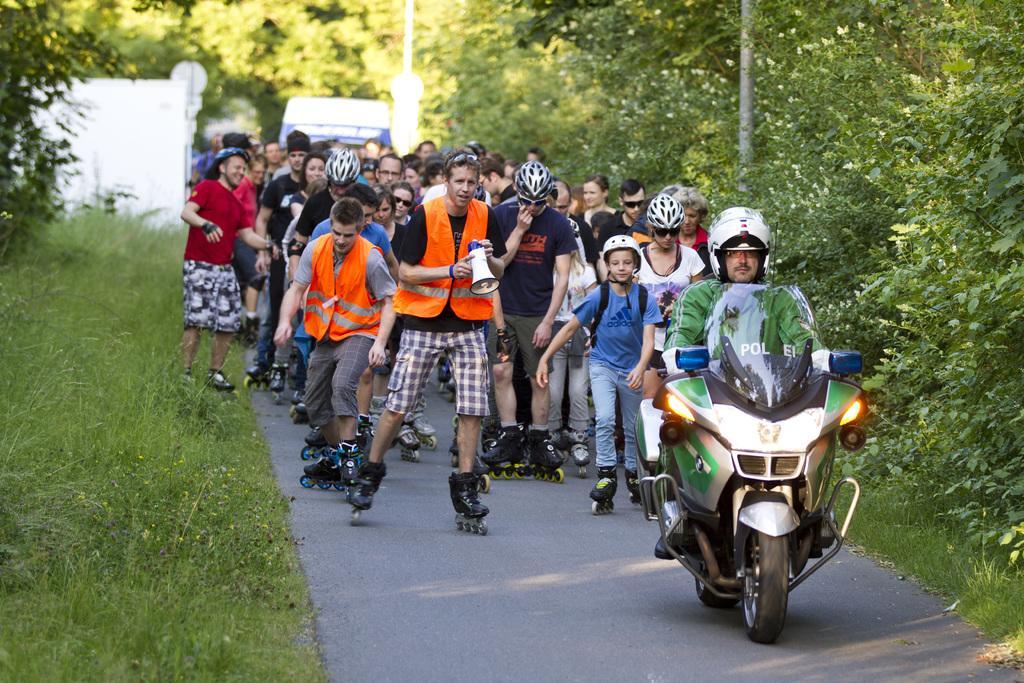Please provide a concise description of this image. This picture is clicked outside. On the right we can see a man wearing a helmet and riding a bike on the ground. In the center we can see the group of people wearing skateboards and skating on the ground. On both the sides we can see the green grass, plants and trees. In the background we can see the poles, group of people, vehicle and the fence like object. 